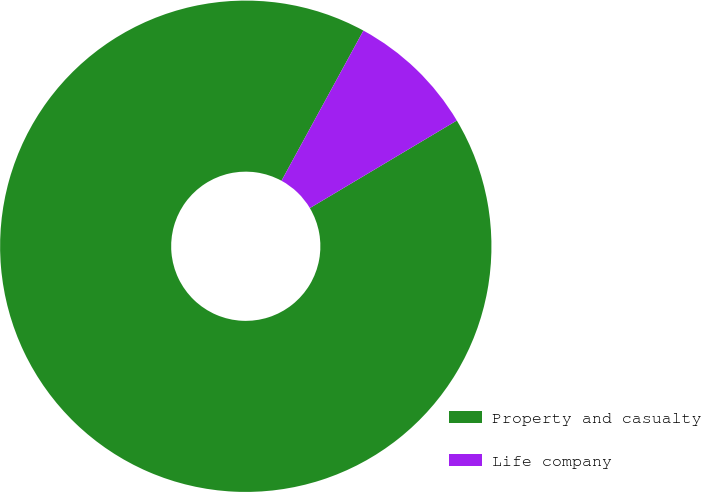Convert chart to OTSL. <chart><loc_0><loc_0><loc_500><loc_500><pie_chart><fcel>Property and casualty<fcel>Life company<nl><fcel>91.5%<fcel>8.5%<nl></chart> 